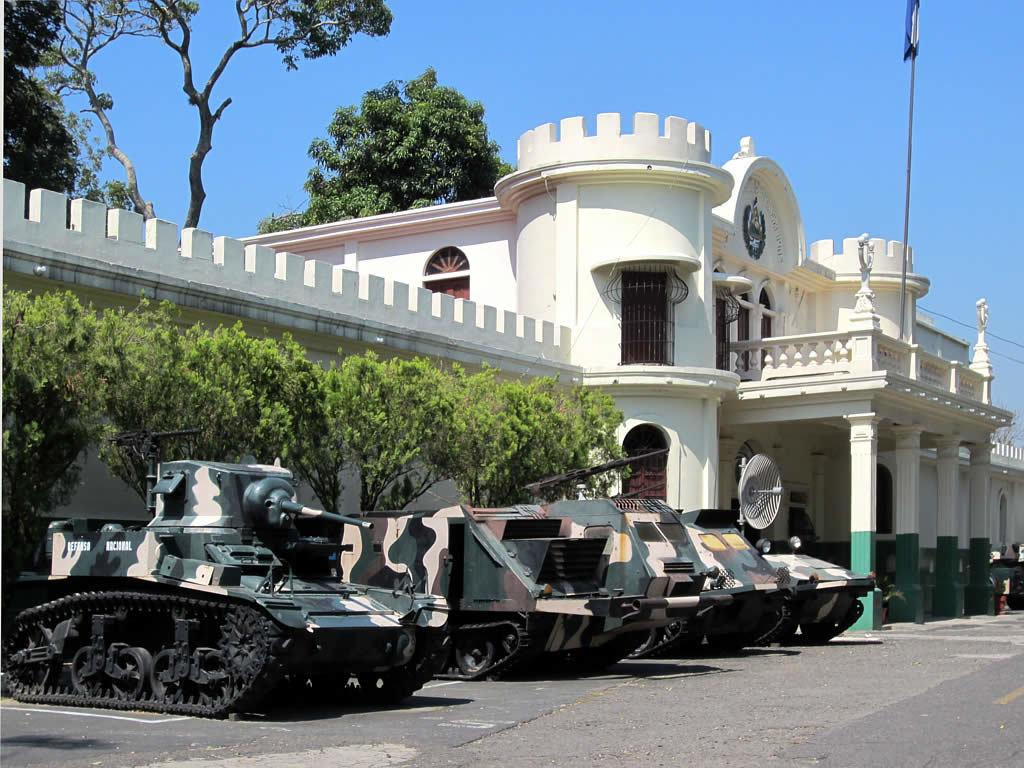What structure is visible in the image? There is a building in the image. What is located in front of the building? There are trees and cannons in front of the building. Are there any other trees visible in the image? Yes, there are more trees in the background of the image. What can be seen in the background of the image besides trees? There is a flag and a blue sky in the background of the image. What type of meat is being grilled on the cannons in the image? A: There is no meat or grilling activity present in the image; the cannons are stationary in front of the building. 